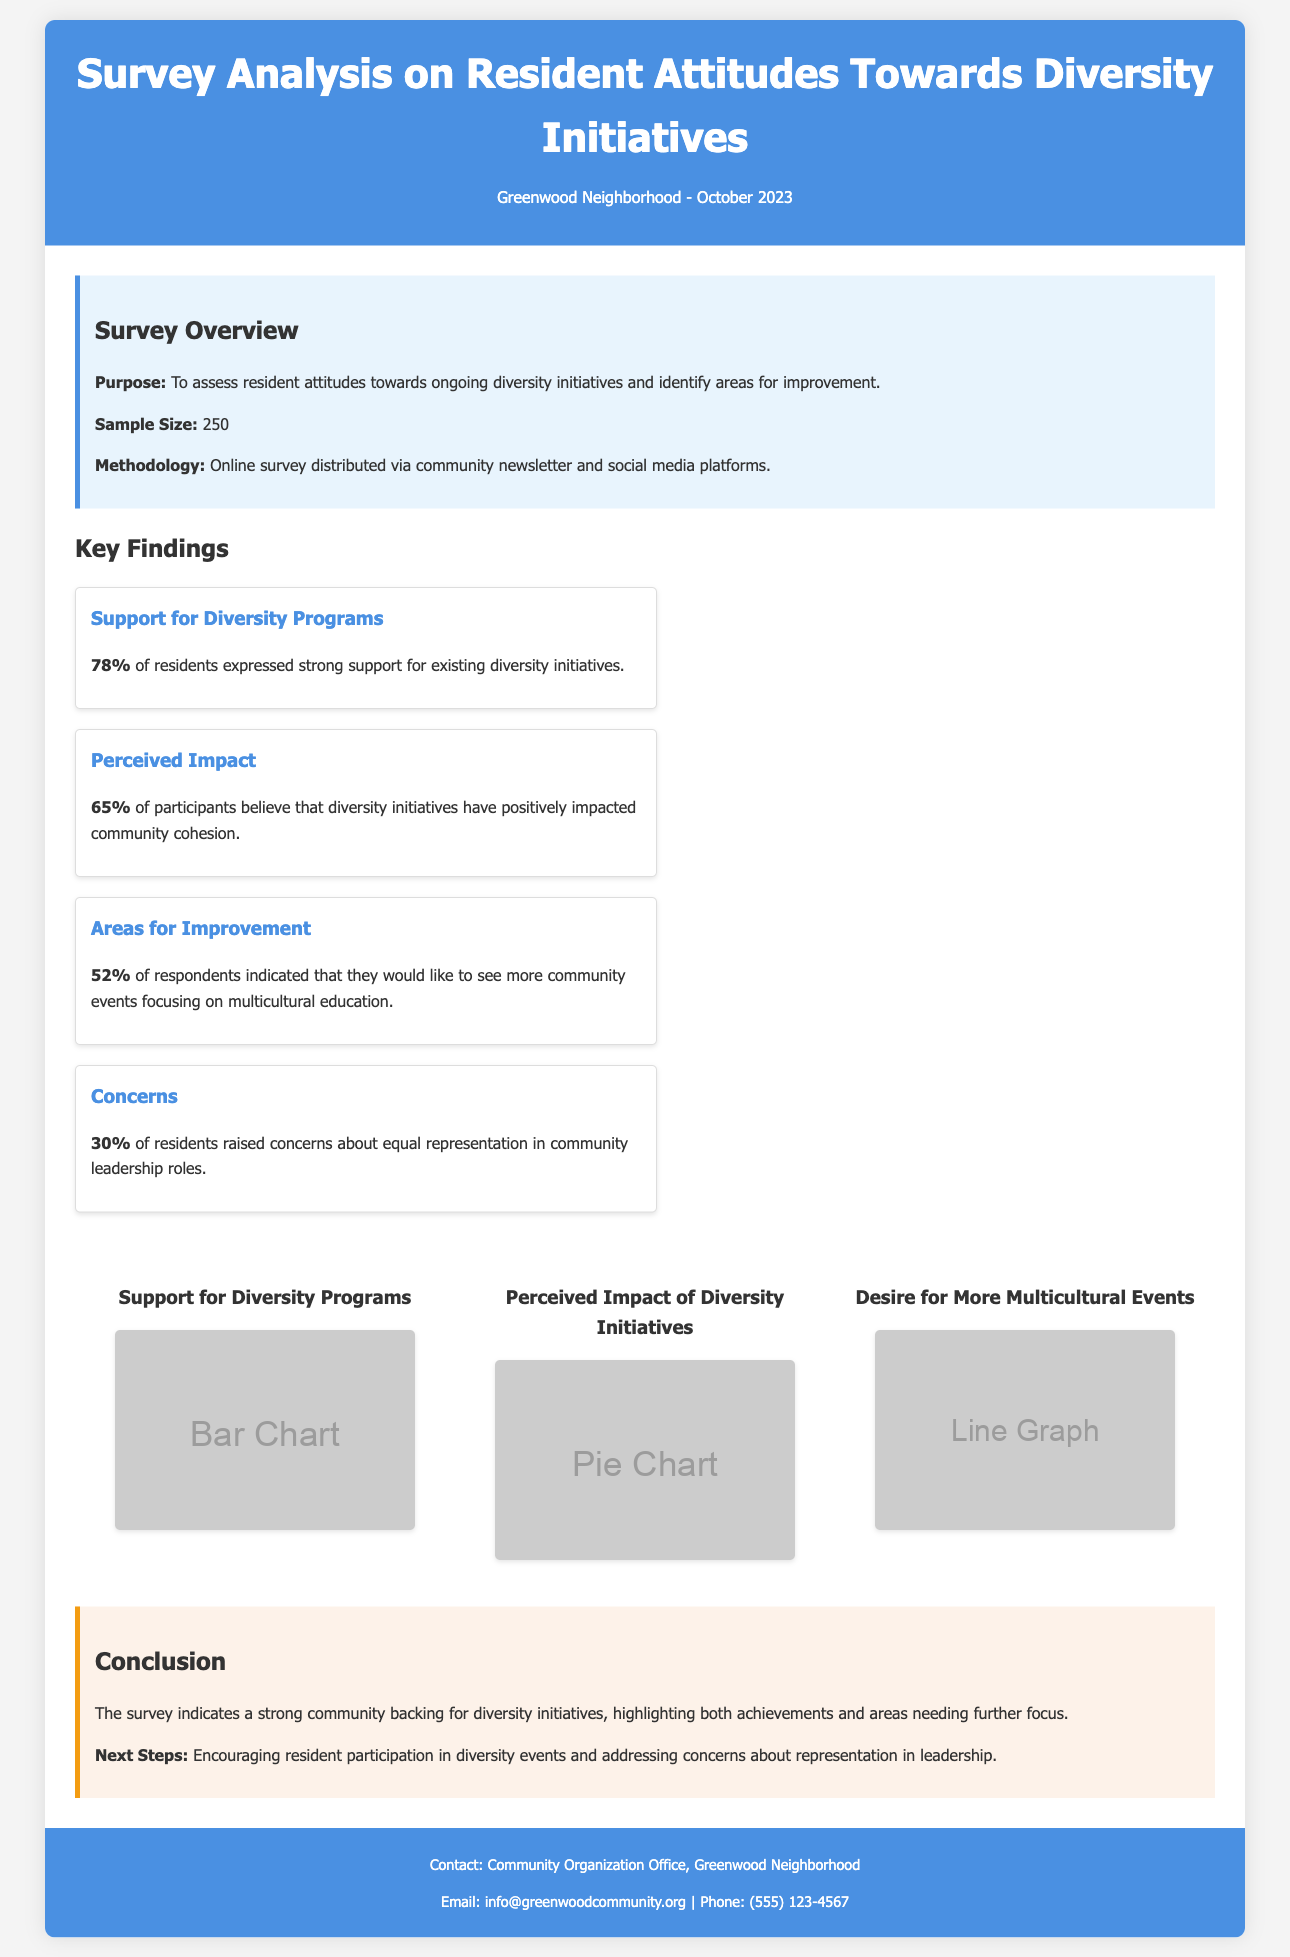What is the sample size of the survey? The sample size is mentioned in the survey overview section of the document, which states it is 250.
Answer: 250 What percentage of residents support existing diversity initiatives? The document highlights that 78% of residents expressed strong support for existing diversity initiatives.
Answer: 78% What do 65% of participants believe about the impact of diversity initiatives? The key findings section notes that 65% of participants believe that diversity initiatives have positively impacted community cohesion.
Answer: Positively impacted community cohesion What area do 52% of respondents want to see more focus on? According to the key findings, 52% of respondents indicated a desire for more community events focusing on multicultural education.
Answer: Multicultural education What percentage of residents raised concerns about equal representation? The document states that 30% of residents raised concerns about equal representation in community leadership roles.
Answer: 30% What is one of the next steps mentioned in the conclusion? The conclusion outlines encouraging resident participation in diversity events as one of the next steps.
Answer: Encouraging resident participation in diversity events What does the survey analyze? The main purpose of the survey is to assess resident attitudes towards ongoing diversity initiatives in the community.
Answer: Resident attitudes towards diversity initiatives What is the methodology used for the survey? The methodology is described in the survey overview section, stating it was an online survey distributed via community newsletter and social media platforms.
Answer: Online survey distributed via community newsletter and social media platforms 